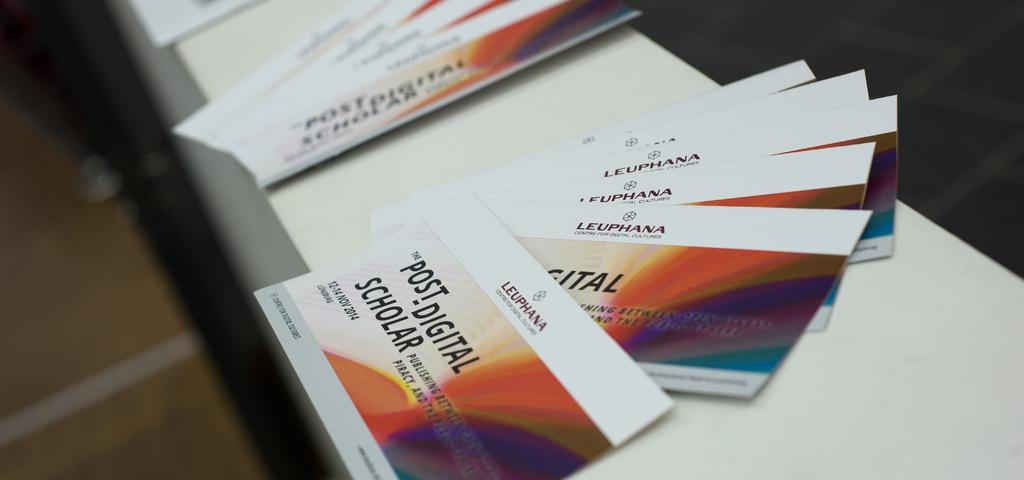<image>
Present a compact description of the photo's key features. Some cards advertise a presentation at the Leuphana Centre for Digital Cultures. 